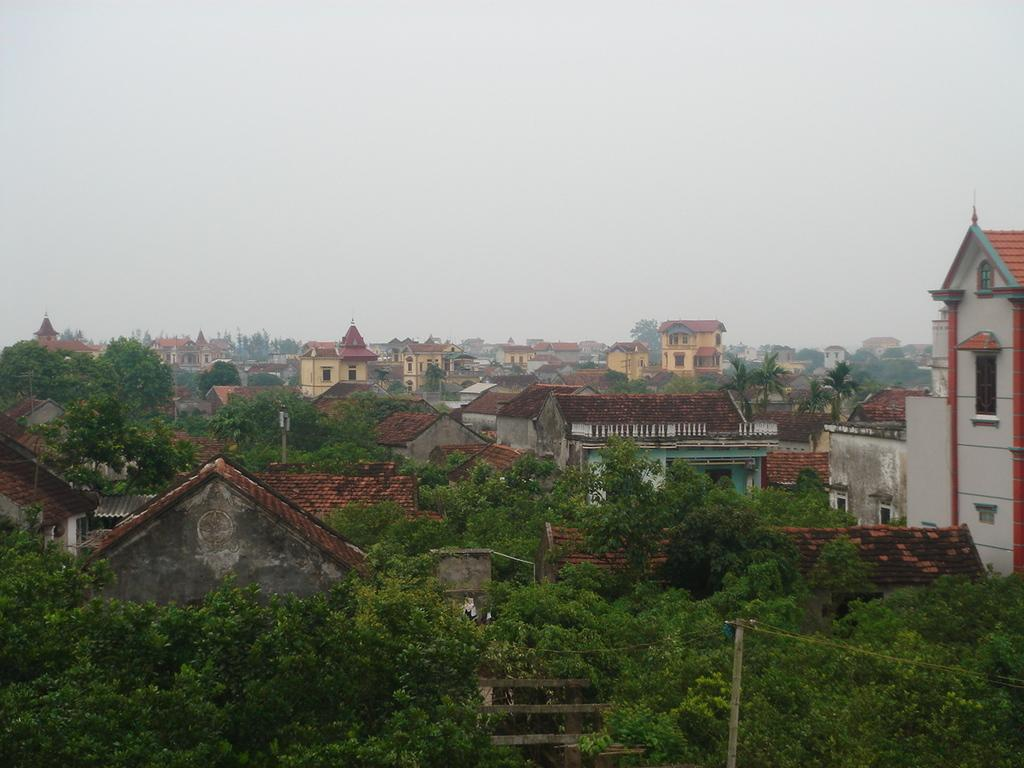What type of view is shown in the image? The image is an outside view. What can be seen at the bottom of the image? There are many trees and buildings at the bottom of the image. What is visible at the top of the image? The sky is visible at the top of the image. How many cows are drinking soda from the tub in the image? There are no cows, soda, or tubs present in the image. 